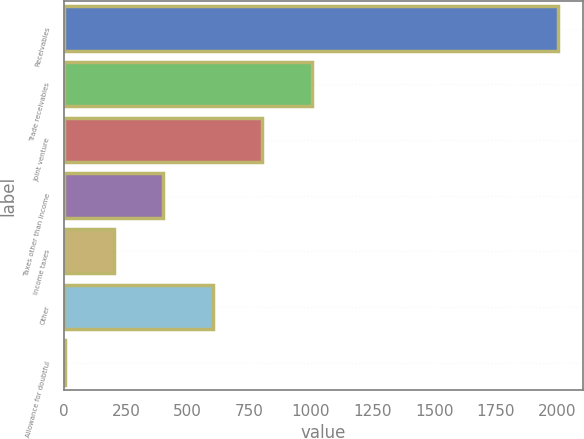<chart> <loc_0><loc_0><loc_500><loc_500><bar_chart><fcel>Receivables<fcel>Trade receivables<fcel>Joint venture<fcel>Taxes other than income<fcel>Income taxes<fcel>Other<fcel>Allowance for doubtful<nl><fcel>2004<fcel>1002.95<fcel>802.74<fcel>402.32<fcel>202.11<fcel>602.53<fcel>1.9<nl></chart> 